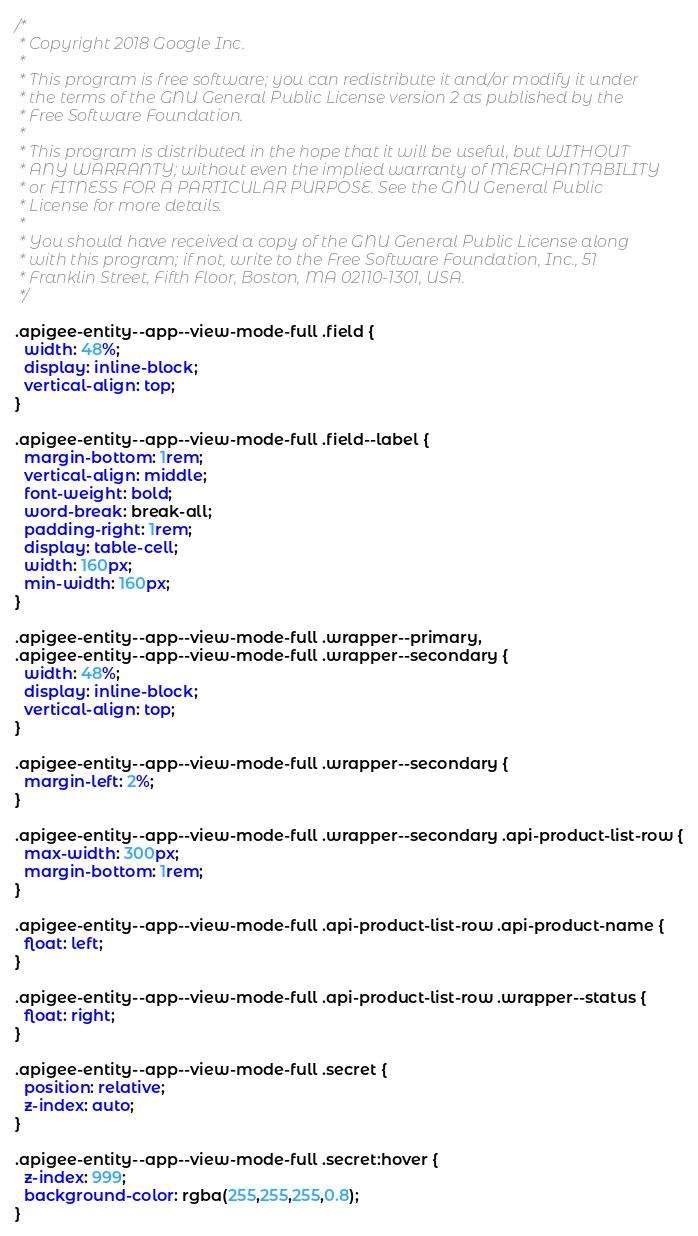Convert code to text. <code><loc_0><loc_0><loc_500><loc_500><_CSS_>/*
 * Copyright 2018 Google Inc.
 *
 * This program is free software; you can redistribute it and/or modify it under
 * the terms of the GNU General Public License version 2 as published by the
 * Free Software Foundation.
 *
 * This program is distributed in the hope that it will be useful, but WITHOUT
 * ANY WARRANTY; without even the implied warranty of MERCHANTABILITY
 * or FITNESS FOR A PARTICULAR PURPOSE. See the GNU General Public
 * License for more details.
 *
 * You should have received a copy of the GNU General Public License along
 * with this program; if not, write to the Free Software Foundation, Inc., 51
 * Franklin Street, Fifth Floor, Boston, MA 02110-1301, USA.
 */

.apigee-entity--app--view-mode-full .field {
  width: 48%;
  display: inline-block;
  vertical-align: top;
}

.apigee-entity--app--view-mode-full .field--label {
  margin-bottom: 1rem;
  vertical-align: middle;
  font-weight: bold;
  word-break: break-all;
  padding-right: 1rem;
  display: table-cell;
  width: 160px;
  min-width: 160px;
}

.apigee-entity--app--view-mode-full .wrapper--primary,
.apigee-entity--app--view-mode-full .wrapper--secondary {
  width: 48%;
  display: inline-block;
  vertical-align: top;
}

.apigee-entity--app--view-mode-full .wrapper--secondary {
  margin-left: 2%;
}

.apigee-entity--app--view-mode-full .wrapper--secondary .api-product-list-row {
  max-width: 300px;
  margin-bottom: 1rem;
}

.apigee-entity--app--view-mode-full .api-product-list-row .api-product-name {
  float: left;
}

.apigee-entity--app--view-mode-full .api-product-list-row .wrapper--status {
  float: right;
}

.apigee-entity--app--view-mode-full .secret {
  position: relative;
  z-index: auto;
}

.apigee-entity--app--view-mode-full .secret:hover {
  z-index: 999;
  background-color: rgba(255,255,255,0.8);
}
</code> 